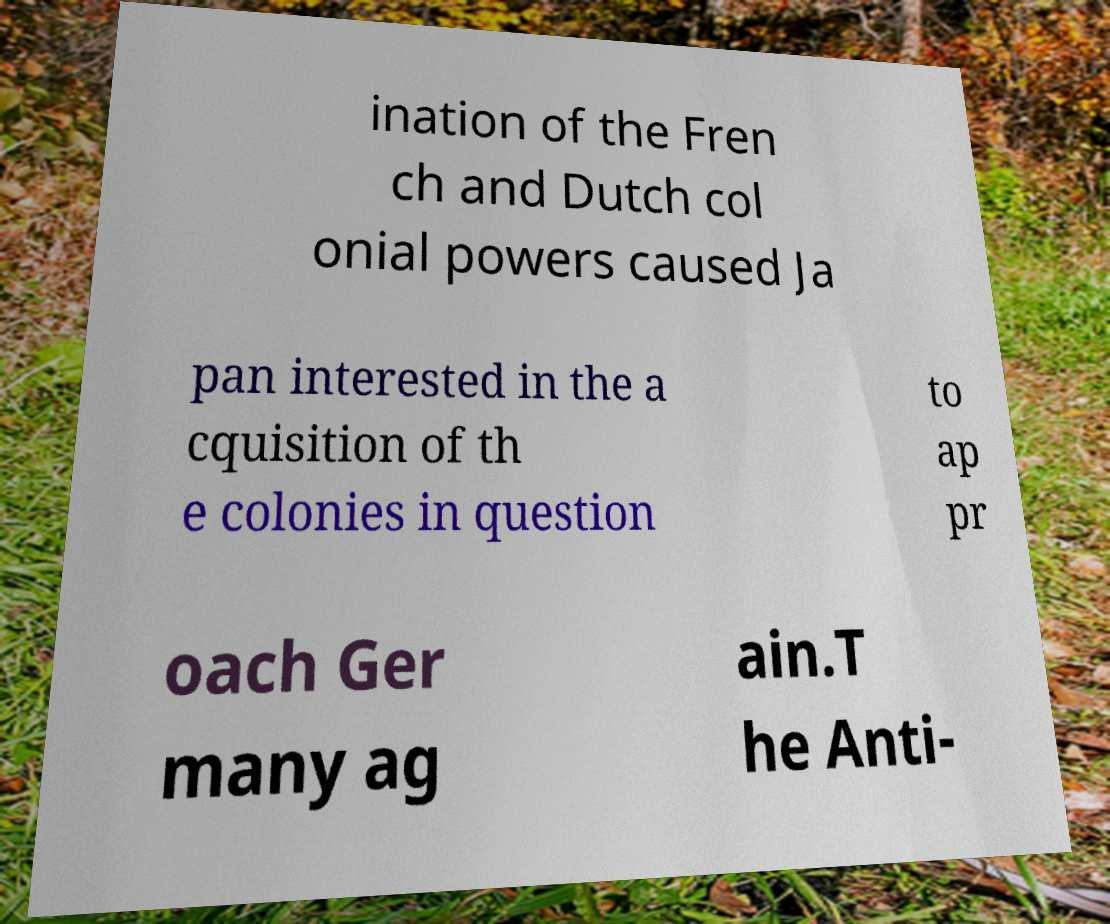For documentation purposes, I need the text within this image transcribed. Could you provide that? ination of the Fren ch and Dutch col onial powers caused Ja pan interested in the a cquisition of th e colonies in question to ap pr oach Ger many ag ain.T he Anti- 